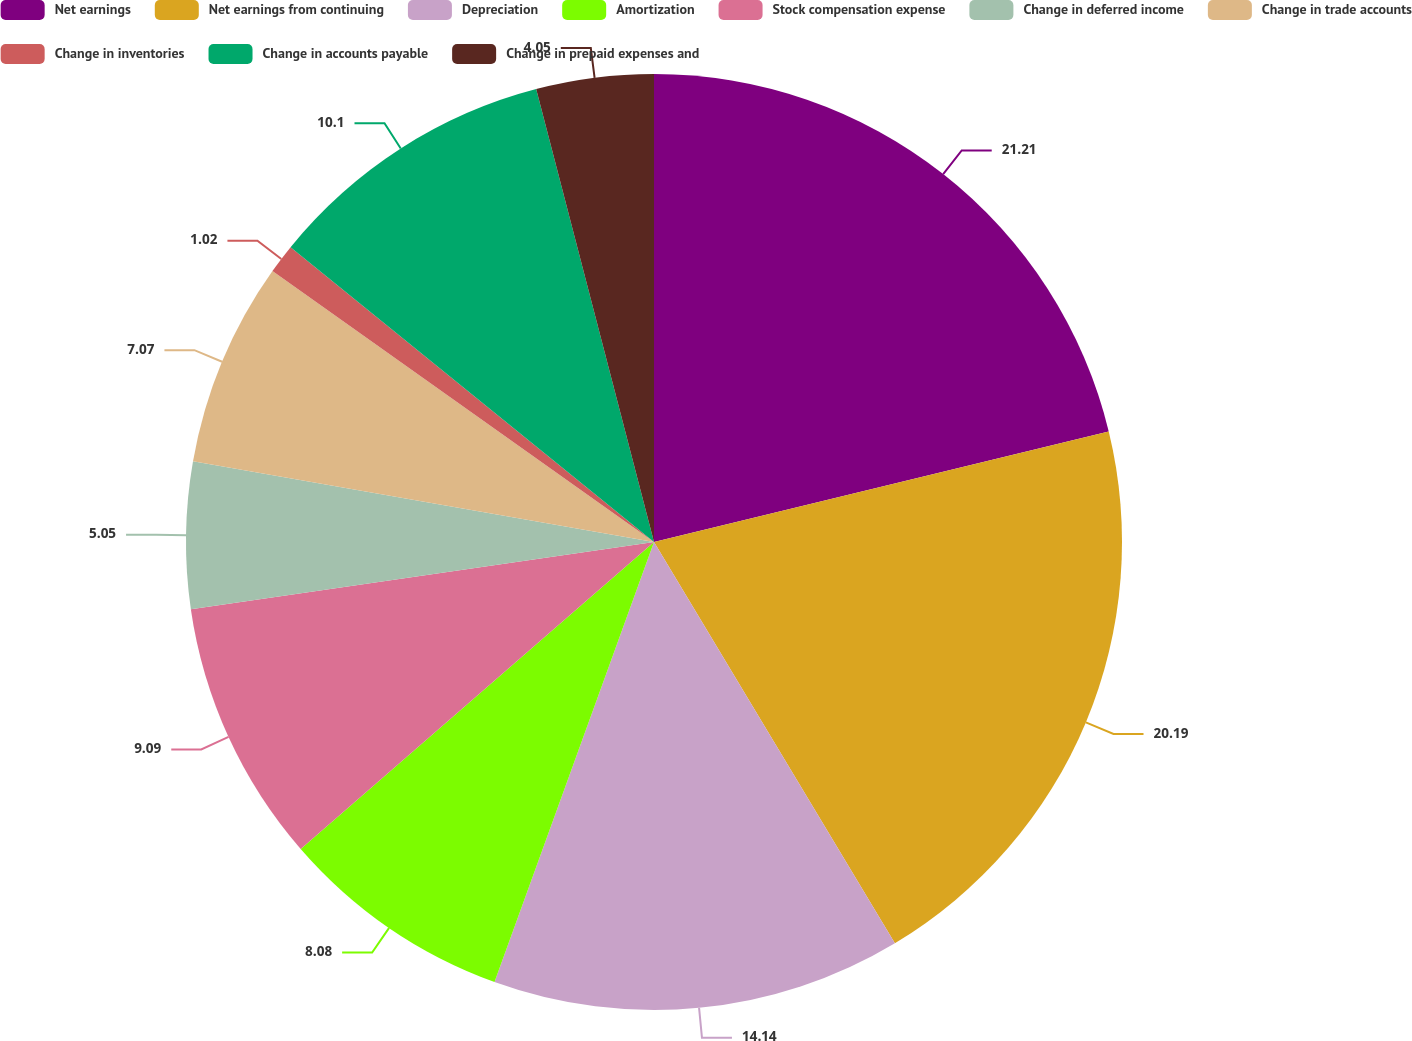Convert chart to OTSL. <chart><loc_0><loc_0><loc_500><loc_500><pie_chart><fcel>Net earnings<fcel>Net earnings from continuing<fcel>Depreciation<fcel>Amortization<fcel>Stock compensation expense<fcel>Change in deferred income<fcel>Change in trade accounts<fcel>Change in inventories<fcel>Change in accounts payable<fcel>Change in prepaid expenses and<nl><fcel>21.2%<fcel>20.19%<fcel>14.14%<fcel>8.08%<fcel>9.09%<fcel>5.05%<fcel>7.07%<fcel>1.02%<fcel>10.1%<fcel>4.05%<nl></chart> 